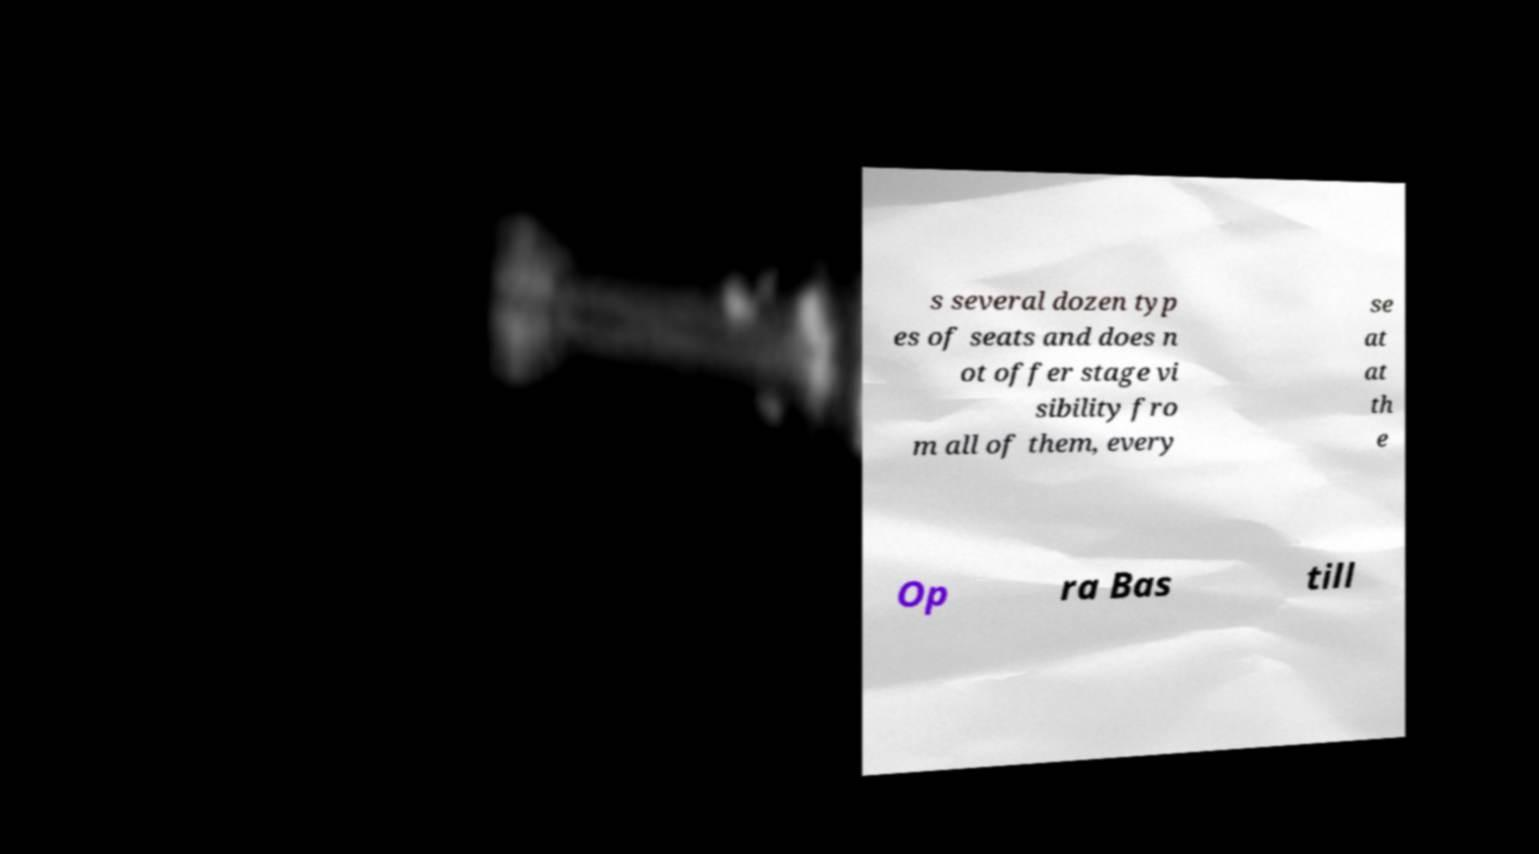Please identify and transcribe the text found in this image. s several dozen typ es of seats and does n ot offer stage vi sibility fro m all of them, every se at at th e Op ra Bas till 